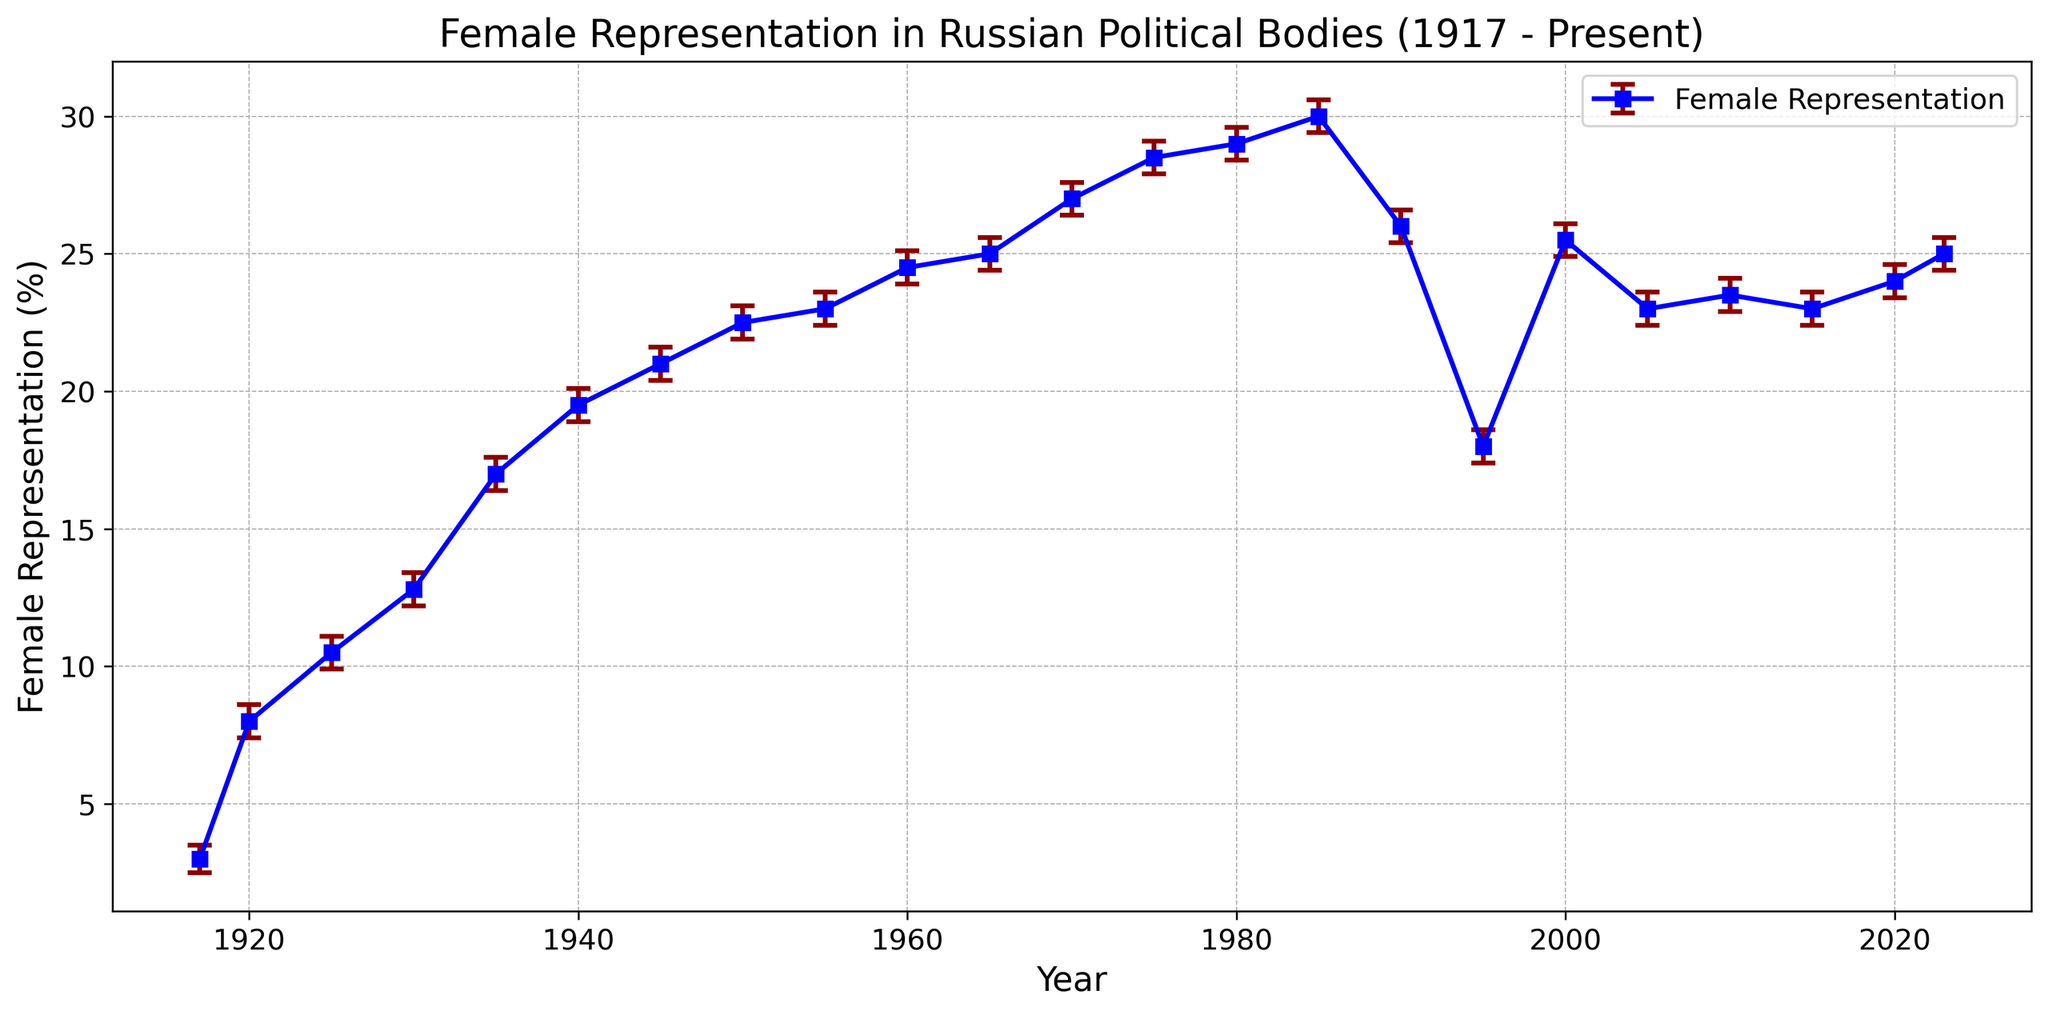What is the percentage change in female representation from 1917 to 1920? The percentage in 1917 is 3.0%, and in 1920 it is 8.0%. The change is calculated as 8.0% - 3.0% = 5.0%.
Answer: 5.0% Which year shows the highest percentage of female representation in the data? The figure shows that the highest percentage of female representation is in 1985 with 30.0%.
Answer: 1985 How does the female representation percentage in 1950 compare to that in 2000? In 1950, the female representation is 22.5%, and in 2000 it is 25.5%. Therefore, the representation increased by 3.0%.
Answer: 3.0% During which period did female representation show a significant decline? Female representation declined significantly between 1985 (30.0%) and 1995 (18.0%).
Answer: 1985 to 1995 What is the average percentage of female representation from 2010 to 2023? The percentages for 2010, 2015, 2020, and 2023 are 23.5%, 23.0%, 24.0%, and 25.0%, respectively. The average is calculated as (23.5 + 23.0 + 24.0 + 25.0) / 4 = 23.875%.
Answer: 23.875% Did female representation ever reach or exceed 30% within the given years? Yes, in 1980 (29.0%) and 1985 (30.0%), it was close to or reached 30%.
Answer: Yes Which decade saw the most consistent increase in female representation? The decade from 1920 to 1930 saw consistent growth as the percentage increased from 8.0% to 12.8%.
Answer: 1920s What are the confidence intervals for the female representation percentage in 1970? The lower bound is 26.4%, and the upper bound is 27.6%.
Answer: 26.4% to 27.6% By how much did female representation change between 1995 and 2005? From 1995 (18.0%) to 2005 (23.0%), the change is 23.0% - 18.0% = 5.0%.
Answer: 5.0% Between which consecutive years did the female representation fluctuate the least? The fluctuation is least between 2010 (23.5%) and 2015 (23.0%), with a difference of 0.5%.
Answer: 2010 and 2015 